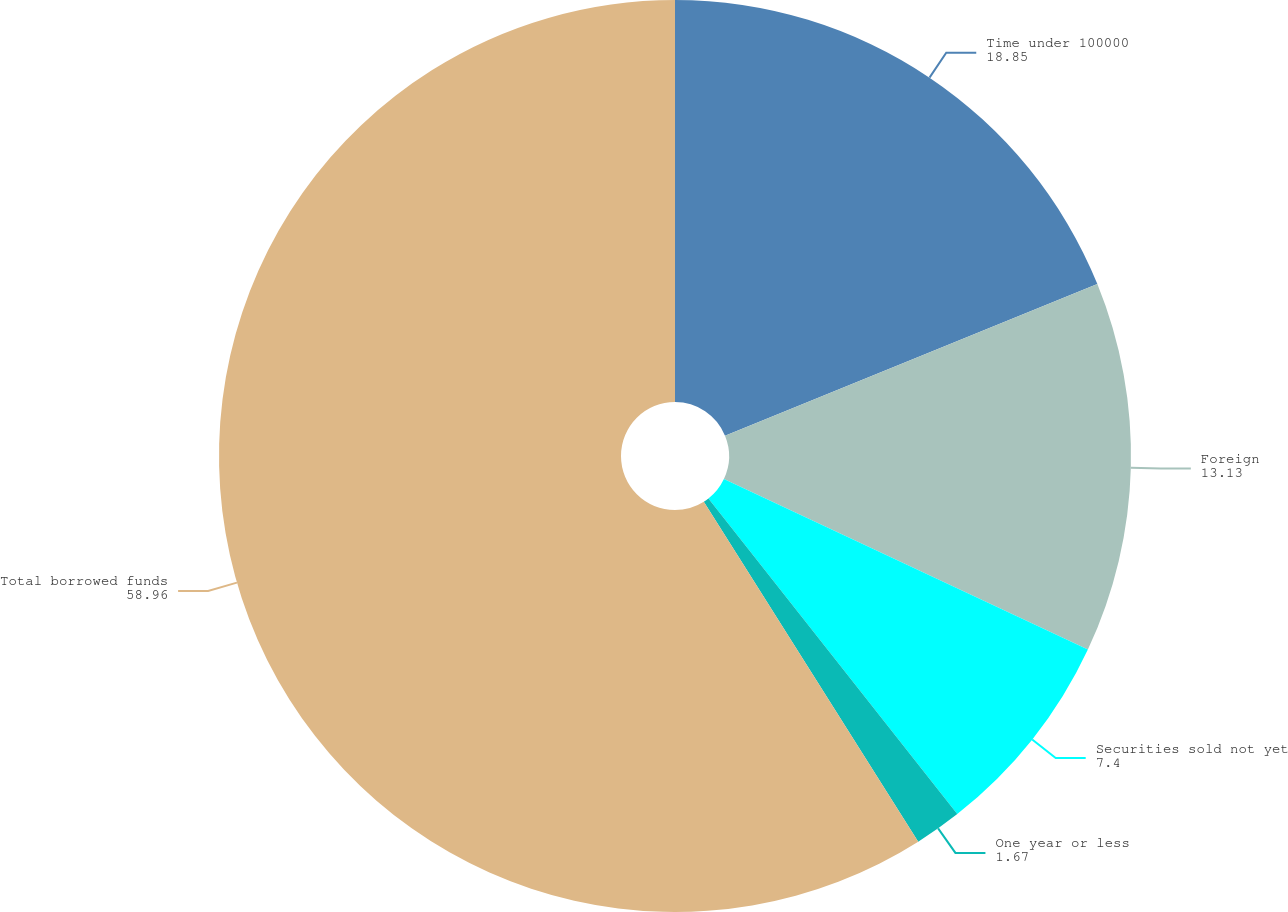<chart> <loc_0><loc_0><loc_500><loc_500><pie_chart><fcel>Time under 100000<fcel>Foreign<fcel>Securities sold not yet<fcel>One year or less<fcel>Total borrowed funds<nl><fcel>18.85%<fcel>13.13%<fcel>7.4%<fcel>1.67%<fcel>58.96%<nl></chart> 